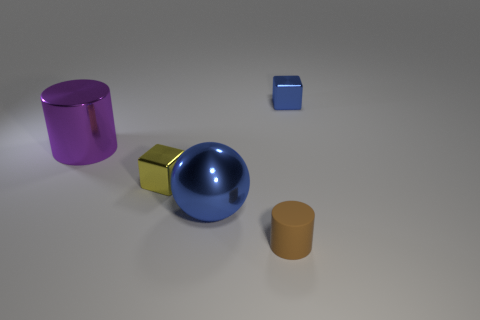How would you describe the texture of the surface in the image? The surface displayed in the image seems to be smooth and uniform with a slight sheen, indicating that it might be made of a polished material such as varnished wood, or perhaps a smooth matte finish on a synthetic surface. The absence of any apparent grain or texture leans towards a non-natural material. 